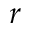<formula> <loc_0><loc_0><loc_500><loc_500>r</formula> 